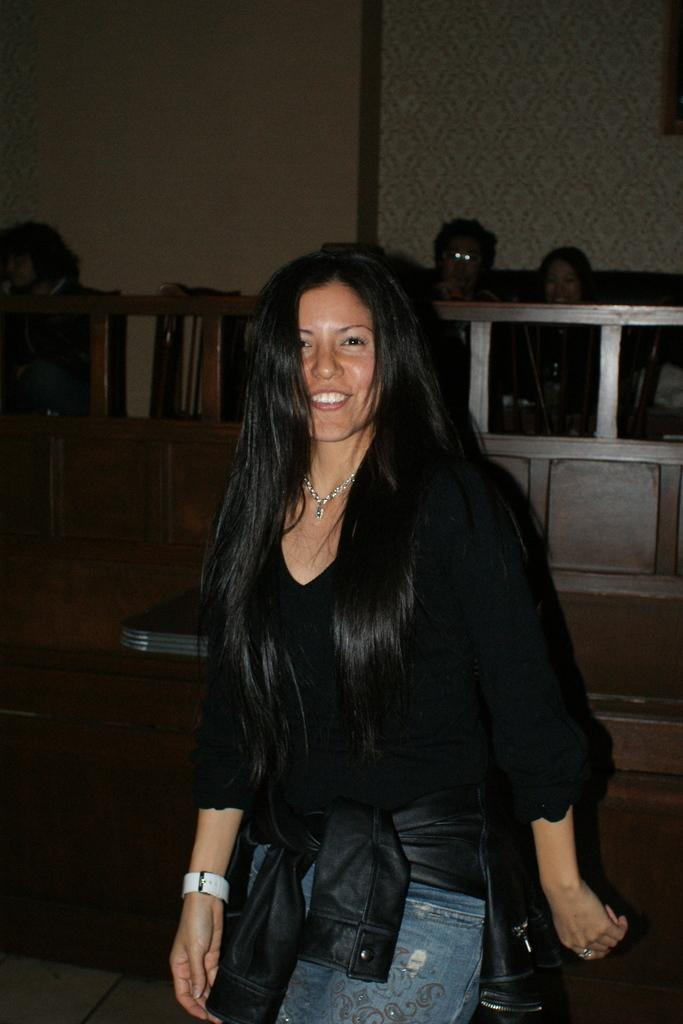Who is present in the image? There is a woman in the image. What is the woman's expression? The woman is smiling. Can you describe the object behind the woman? Unfortunately, the facts provided do not give any information about the object behind the woman. What can be seen in the background of the image? There is a fence, people, and a wall in the background of the image. What type of bomb can be seen in the image? There is no bomb present in the image. What color is the woman's sweater in the image? The facts provided do not give any information about the color or type of clothing the woman is wearing. 